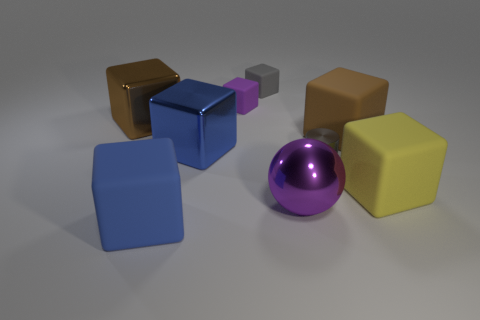What shape is the thing that is the same color as the cylinder?
Your response must be concise. Cube. What number of blue metallic objects are behind the large brown thing that is behind the brown cube on the right side of the purple rubber object?
Your answer should be compact. 0. What is the size of the thing that is to the left of the blue thing in front of the large yellow rubber block?
Your answer should be very brief. Large. What is the size of the purple object that is the same material as the yellow object?
Your answer should be compact. Small. The big rubber thing that is both on the left side of the large yellow cube and right of the large purple thing has what shape?
Make the answer very short. Cube. Are there the same number of tiny things in front of the small gray matte block and large brown rubber objects?
Keep it short and to the point. No. How many objects are big yellow rubber blocks or large objects on the left side of the small shiny object?
Ensure brevity in your answer.  5. Are there any cyan shiny things that have the same shape as the large brown matte thing?
Provide a succinct answer. No. Are there the same number of brown blocks that are in front of the big purple thing and large purple objects on the left side of the brown shiny block?
Give a very brief answer. Yes. Is there any other thing that has the same size as the gray rubber object?
Make the answer very short. Yes. 